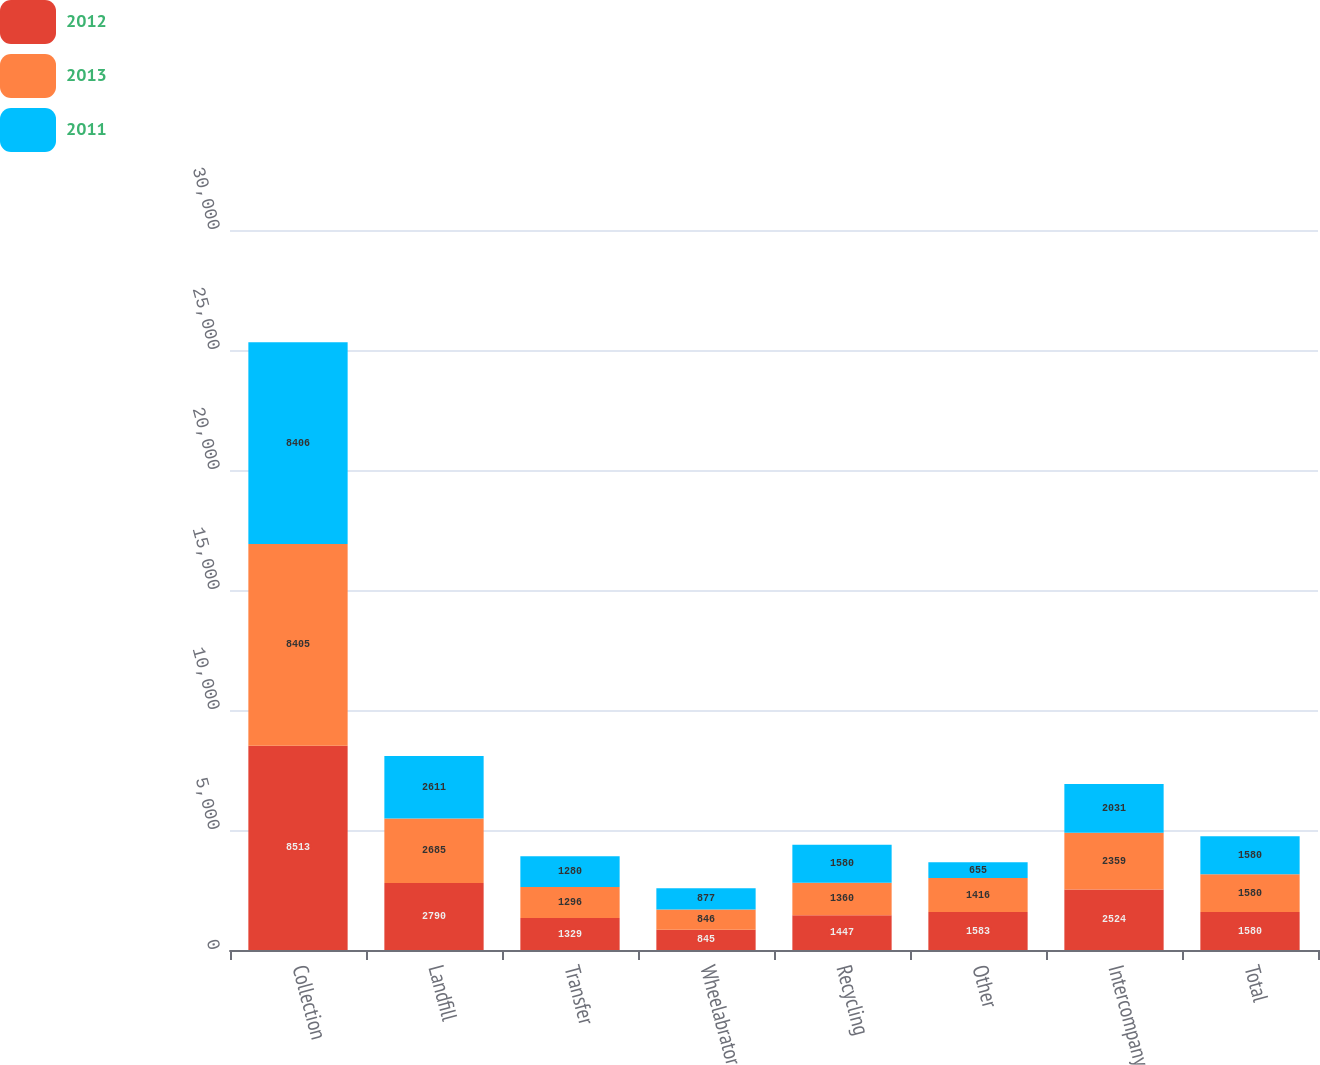Convert chart to OTSL. <chart><loc_0><loc_0><loc_500><loc_500><stacked_bar_chart><ecel><fcel>Collection<fcel>Landfill<fcel>Transfer<fcel>Wheelabrator<fcel>Recycling<fcel>Other<fcel>Intercompany<fcel>Total<nl><fcel>2012<fcel>8513<fcel>2790<fcel>1329<fcel>845<fcel>1447<fcel>1583<fcel>2524<fcel>1580<nl><fcel>2013<fcel>8405<fcel>2685<fcel>1296<fcel>846<fcel>1360<fcel>1416<fcel>2359<fcel>1580<nl><fcel>2011<fcel>8406<fcel>2611<fcel>1280<fcel>877<fcel>1580<fcel>655<fcel>2031<fcel>1580<nl></chart> 